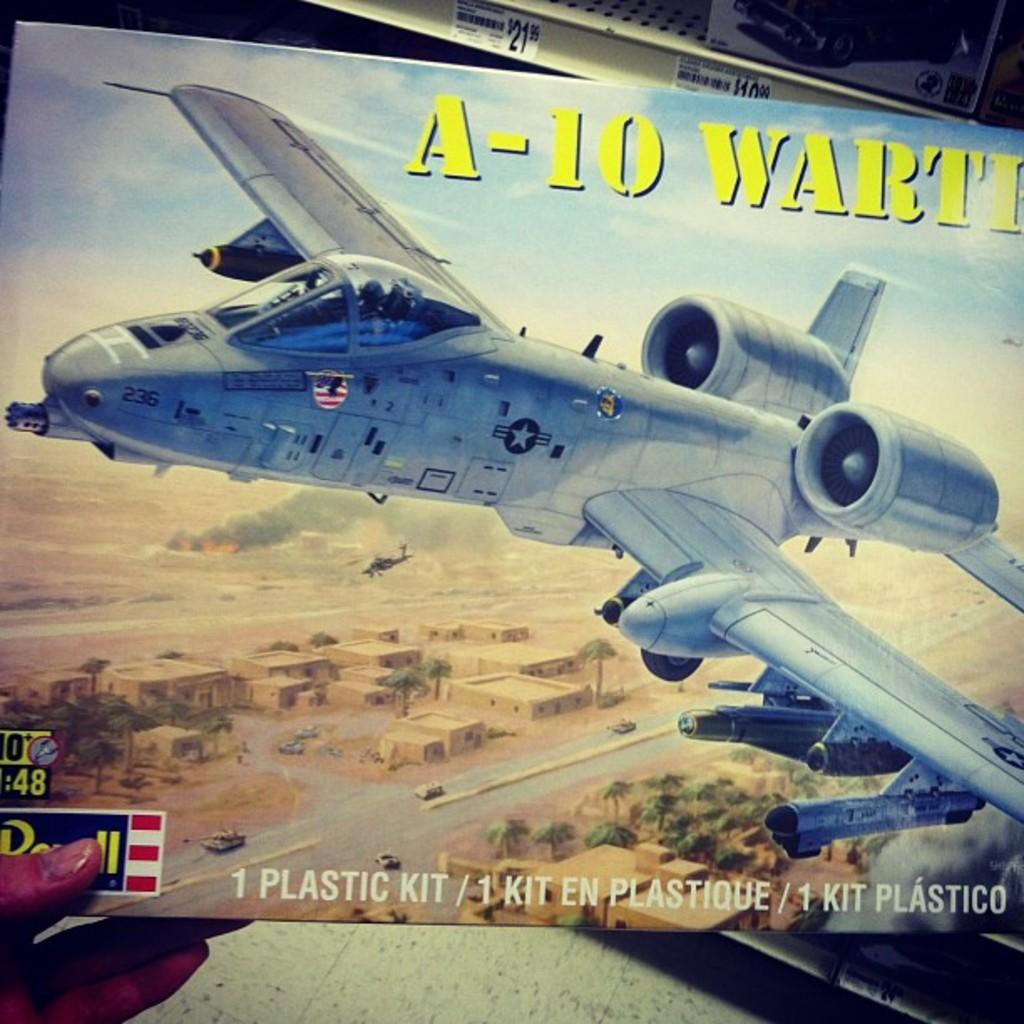<image>
Summarize the visual content of the image. A plastic aircraft kit to build an A-10 comes in a box with a picture of the aircraft on the cover. 